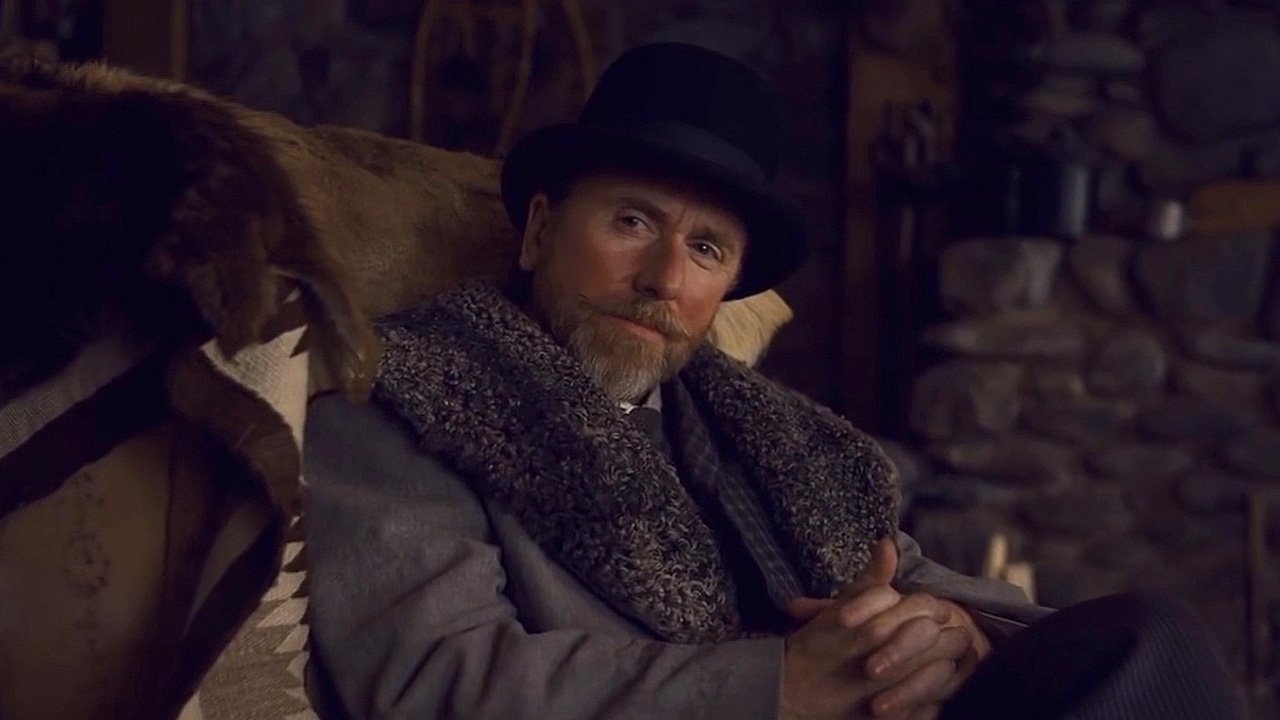What do you see happening in this image? The image depicts a man with a serious and contemplative demeanor. He is seated in a rustic setting, dressed in a period-style costume with a black top hat and a thick, fur-lined coat. His crossed arms and stern expression, coupled with the vintage-style clothing, might suggest he is a character from a historical or period drama. The backdrop features a stone wall and a wooden shelf, which contributes to the old-fashioned, perhaps early 20th-century European atmosphere. 